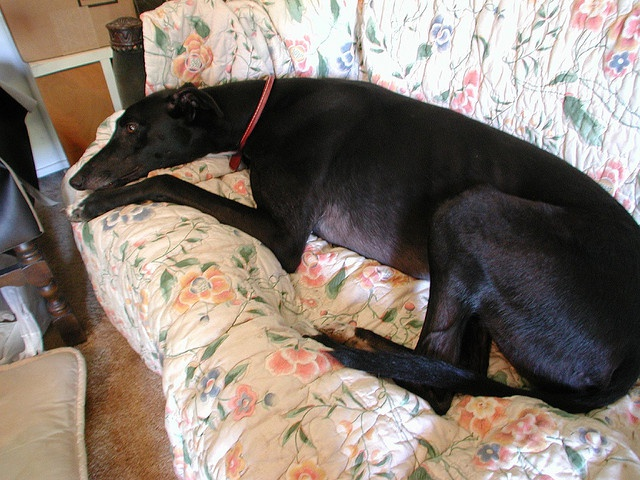Describe the objects in this image and their specific colors. I can see couch in gray, white, tan, and darkgray tones and dog in gray, black, and maroon tones in this image. 